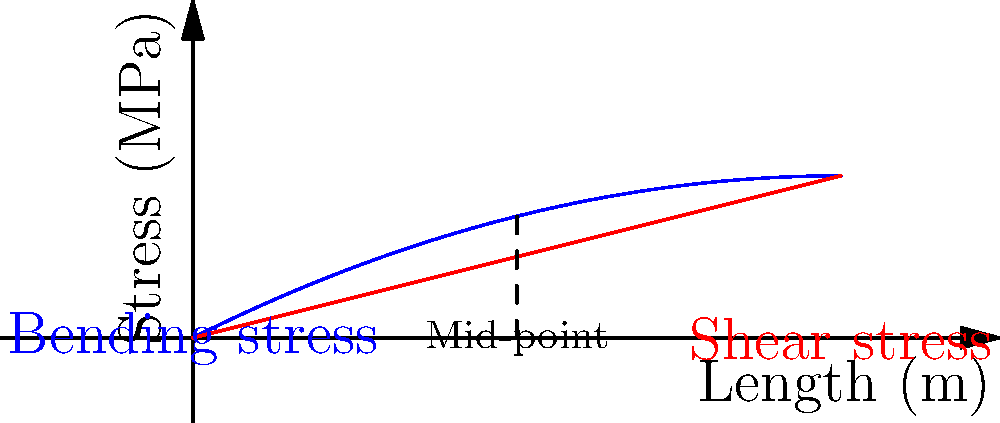In the stress distribution diagram for a simply supported beam under uniform load, which type of stress is typically higher at the mid-point of the beam? Explain your reasoning using the graph and your knowledge of beam mechanics. Let's analyze the stress distribution in the beam step-by-step:

1. The blue curve represents the bending stress distribution along the beam length.
2. The red line represents the shear stress distribution along the beam length.

3. Bending stress:
   - Reaches its maximum at the mid-point of the beam.
   - This is because the bending moment is highest at the center for a simply supported beam under uniform load.
   - The bending stress follows a parabolic distribution, as shown by the blue curve.

4. Shear stress:
   - Is maximum at the supports and decreases linearly towards the center.
   - At the mid-point, the shear stress is zero for a symmetrically loaded beam.
   - This is represented by the red line in the graph.

5. At the mid-point (indicated by the dashed line):
   - The bending stress is at its peak value.
   - The shear stress is zero.

6. Therefore, at the mid-point, the bending stress is higher than the shear stress.

This stress distribution is crucial for designing beams in structures like bridges or buildings, where the maximum stresses determine the required strength of the material.
Answer: Bending stress is higher at the mid-point. 